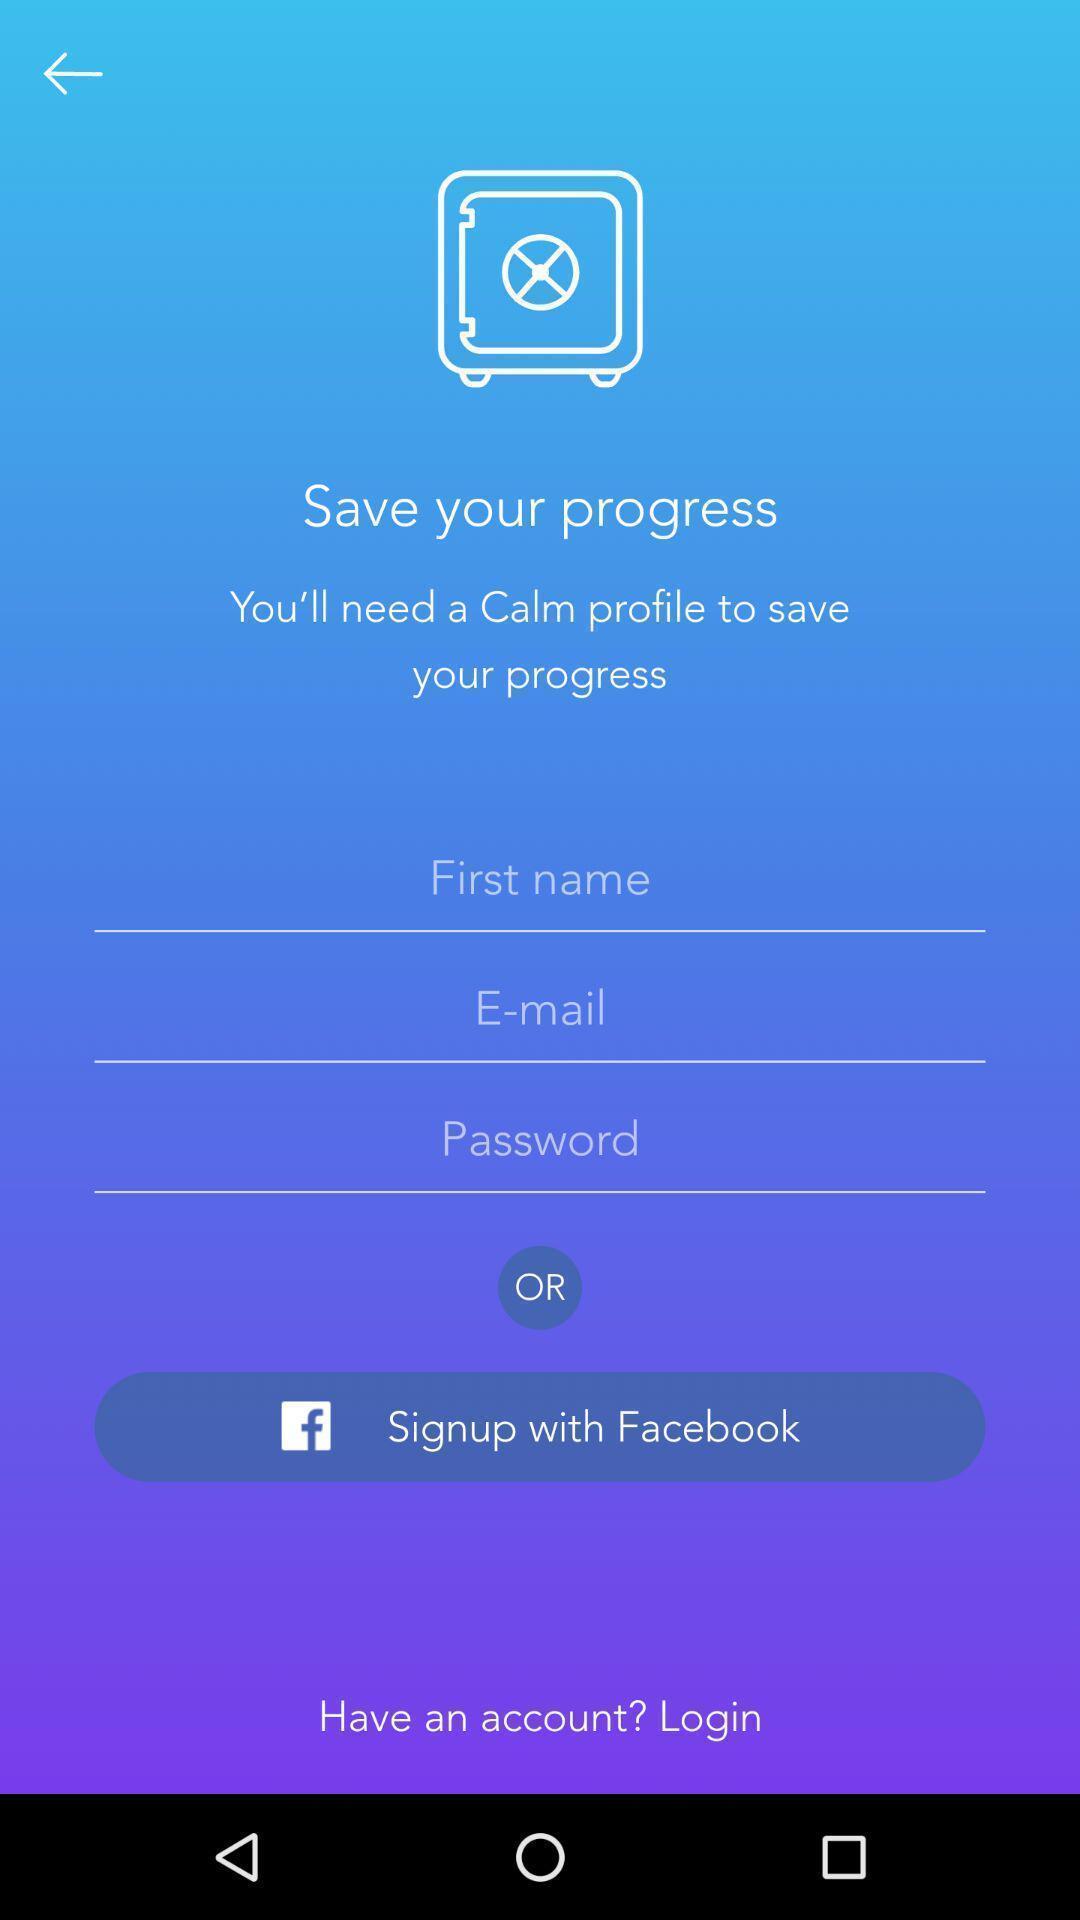Provide a description of this screenshot. Two options are showing to sign-up. 